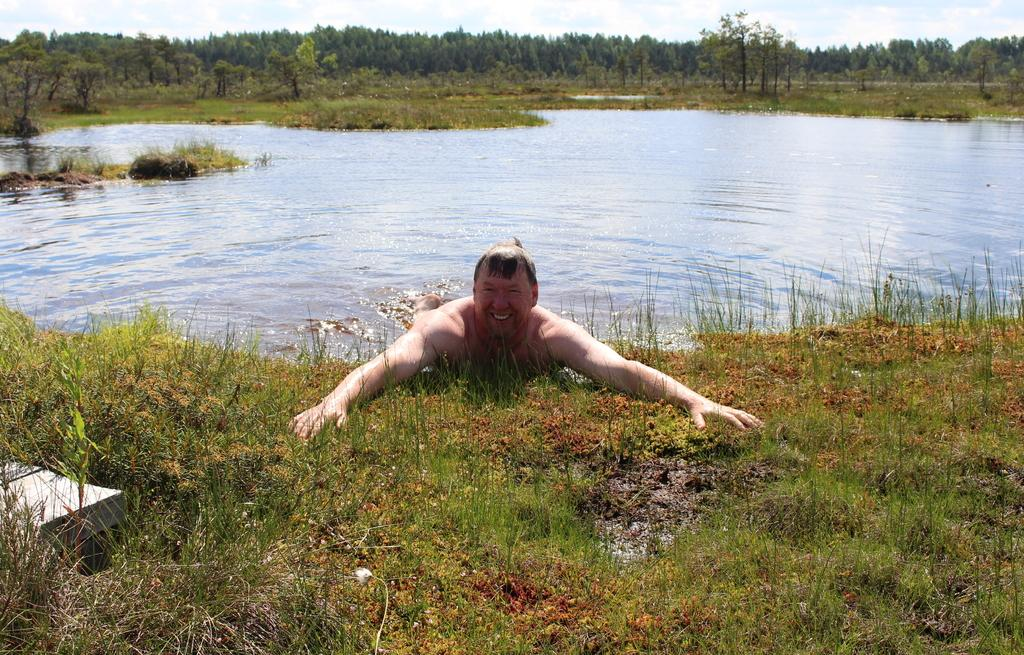Who or what is present in the image? There is a person in the image. What type of terrain is visible in the image? There is grass on the ground in the image. What natural feature can be seen in the image? There is water visible in the image. What type of vegetation is present in the image? There are trees in the image. What is visible in the background of the image? The sky is visible in the background of the image. What type of boot can be seen gripping the person's flesh in the image? There is no boot or flesh visible in the image; it only features a person, grass, water, trees, and the sky. 